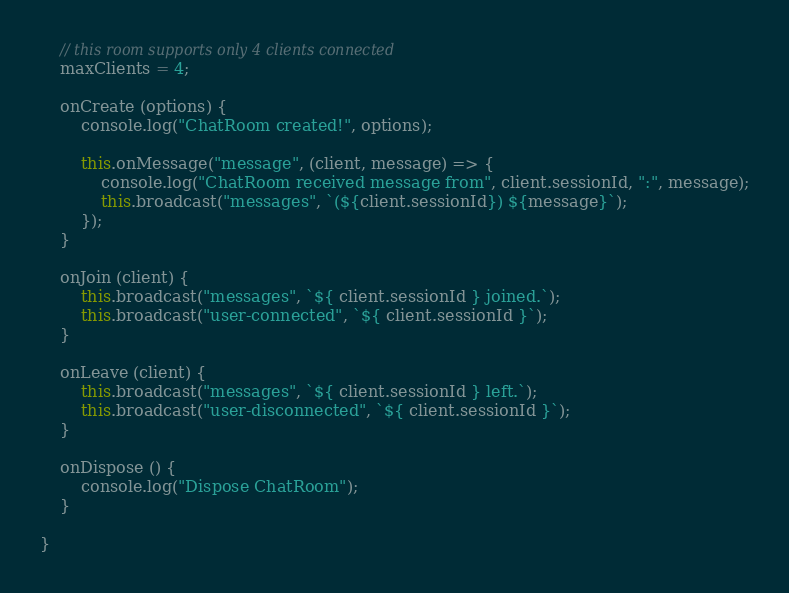<code> <loc_0><loc_0><loc_500><loc_500><_TypeScript_>    // this room supports only 4 clients connected
    maxClients = 4;

    onCreate (options) {
        console.log("ChatRoom created!", options);

        this.onMessage("message", (client, message) => {
            console.log("ChatRoom received message from", client.sessionId, ":", message);
            this.broadcast("messages", `(${client.sessionId}) ${message}`);
        });
    }

    onJoin (client) {
        this.broadcast("messages", `${ client.sessionId } joined.`);
        this.broadcast("user-connected", `${ client.sessionId }`);
    }

    onLeave (client) {
        this.broadcast("messages", `${ client.sessionId } left.`);
        this.broadcast("user-disconnected", `${ client.sessionId }`);
    }

    onDispose () {
        console.log("Dispose ChatRoom");
    }

}
</code> 